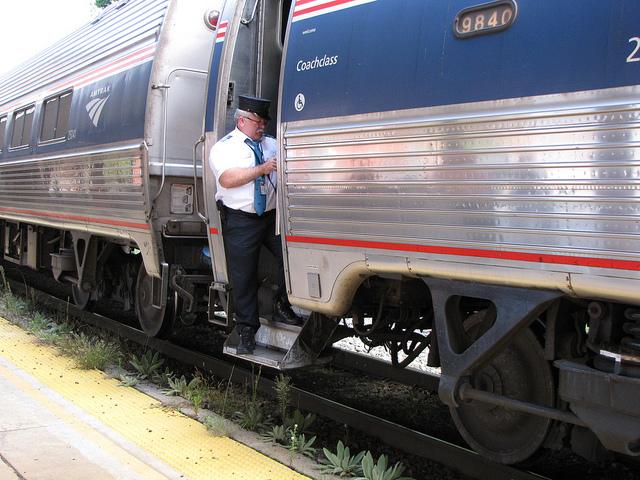How many passengers are there?
Be succinct. 0. What is the last number in the train number?
Write a very short answer. 0. What color is the man's tie?
Keep it brief. Blue. 